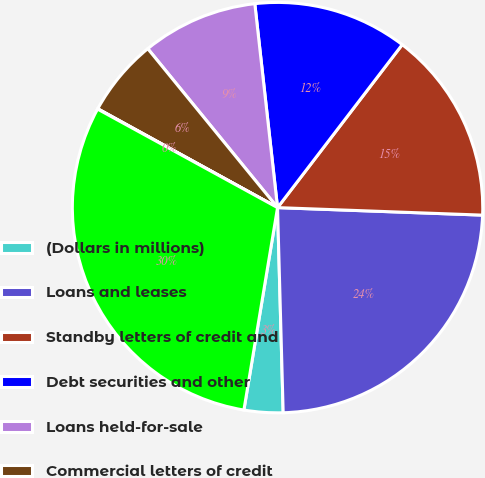Convert chart to OTSL. <chart><loc_0><loc_0><loc_500><loc_500><pie_chart><fcel>(Dollars in millions)<fcel>Loans and leases<fcel>Standby letters of credit and<fcel>Debt securities and other<fcel>Loans held-for-sale<fcel>Commercial letters of credit<fcel>Bankers' acceptances<fcel>Total<nl><fcel>3.06%<fcel>23.98%<fcel>15.19%<fcel>12.16%<fcel>9.13%<fcel>6.1%<fcel>0.03%<fcel>30.35%<nl></chart> 